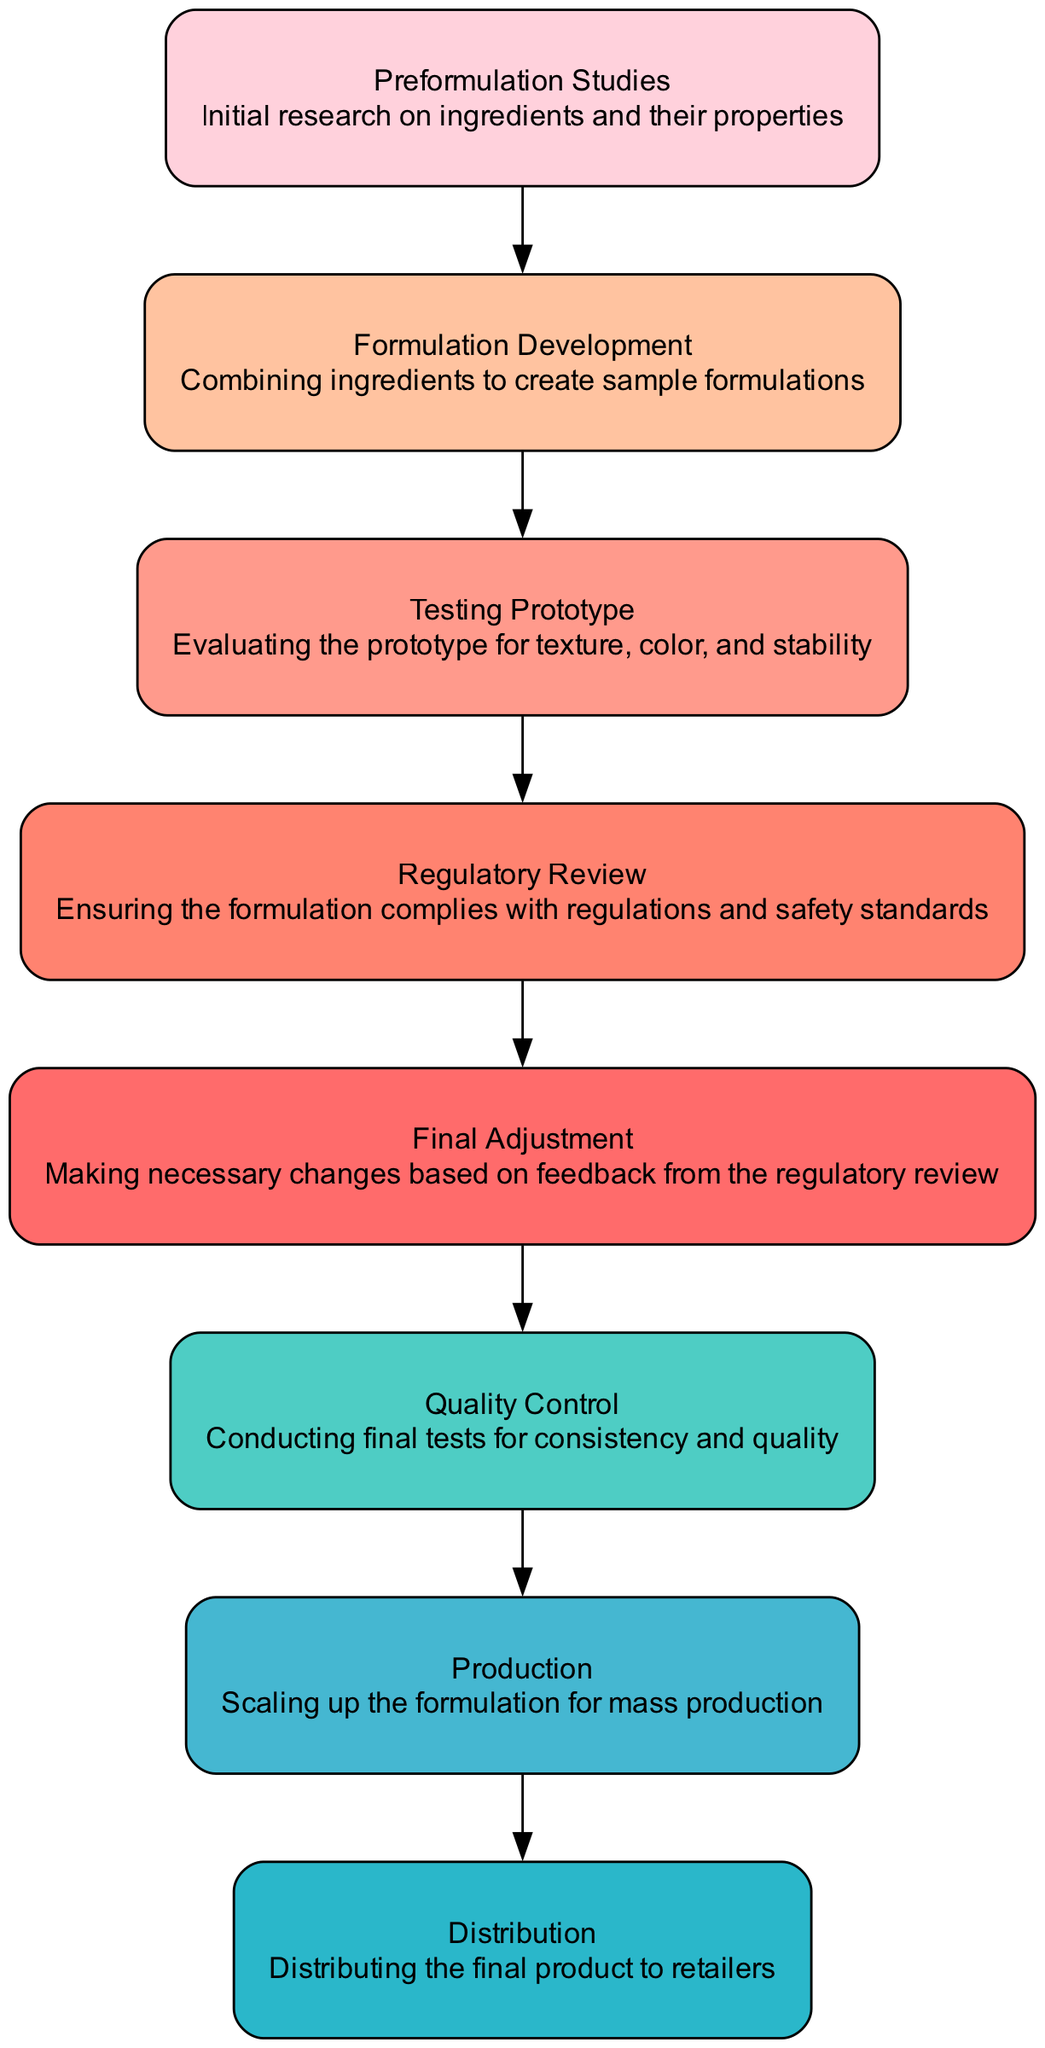What is the first step in the formulation process? The first step shown in the diagram is "Preformulation Studies". This is indicated as the initial node before any other processes take place in the flow.
Answer: Preformulation Studies How many total steps are there in the formulation process? By counting the numbered nodes in the diagram, we find that there are eight distinct steps involved in the formulation process of the lipstick.
Answer: Eight Which process comes after "Testing Prototype"? The diagram clearly indicates that the process following "Testing Prototype" is "Regulatory Review". This can be seen as the arrow leads directly from one to the next.
Answer: Regulatory Review What is the last step before distribution? The diagram specifies that the final step before "Distribution" is "Production". This step is immediately before the distribution node in the flow.
Answer: Production Which step requires making changes based on feedback? According to the diagram, "Final Adjustment" is the step where necessary changes are made based on feedback from the "Regulatory Review". This is highlighted in the flow from one to the next.
Answer: Final Adjustment How many outputs does "Formulation Development" have? The diagram shows that "Formulation Development" has one output, which is "Testing Prototype", indicated by the arrow leading out from that node.
Answer: One What's the purpose of the "Quality Control" step? The diagram describes "Quality Control" as the step where final tests for consistency and quality are conducted. This is noted in the description of the node.
Answer: Conducting final tests for consistency and quality What is the relationship between "Production" and "Distribution"? The diagram illustrates that "Production" directly leads to "Distribution", indicating that after producing the lipstick, the next step is to distribute it.
Answer: Directly leads to 